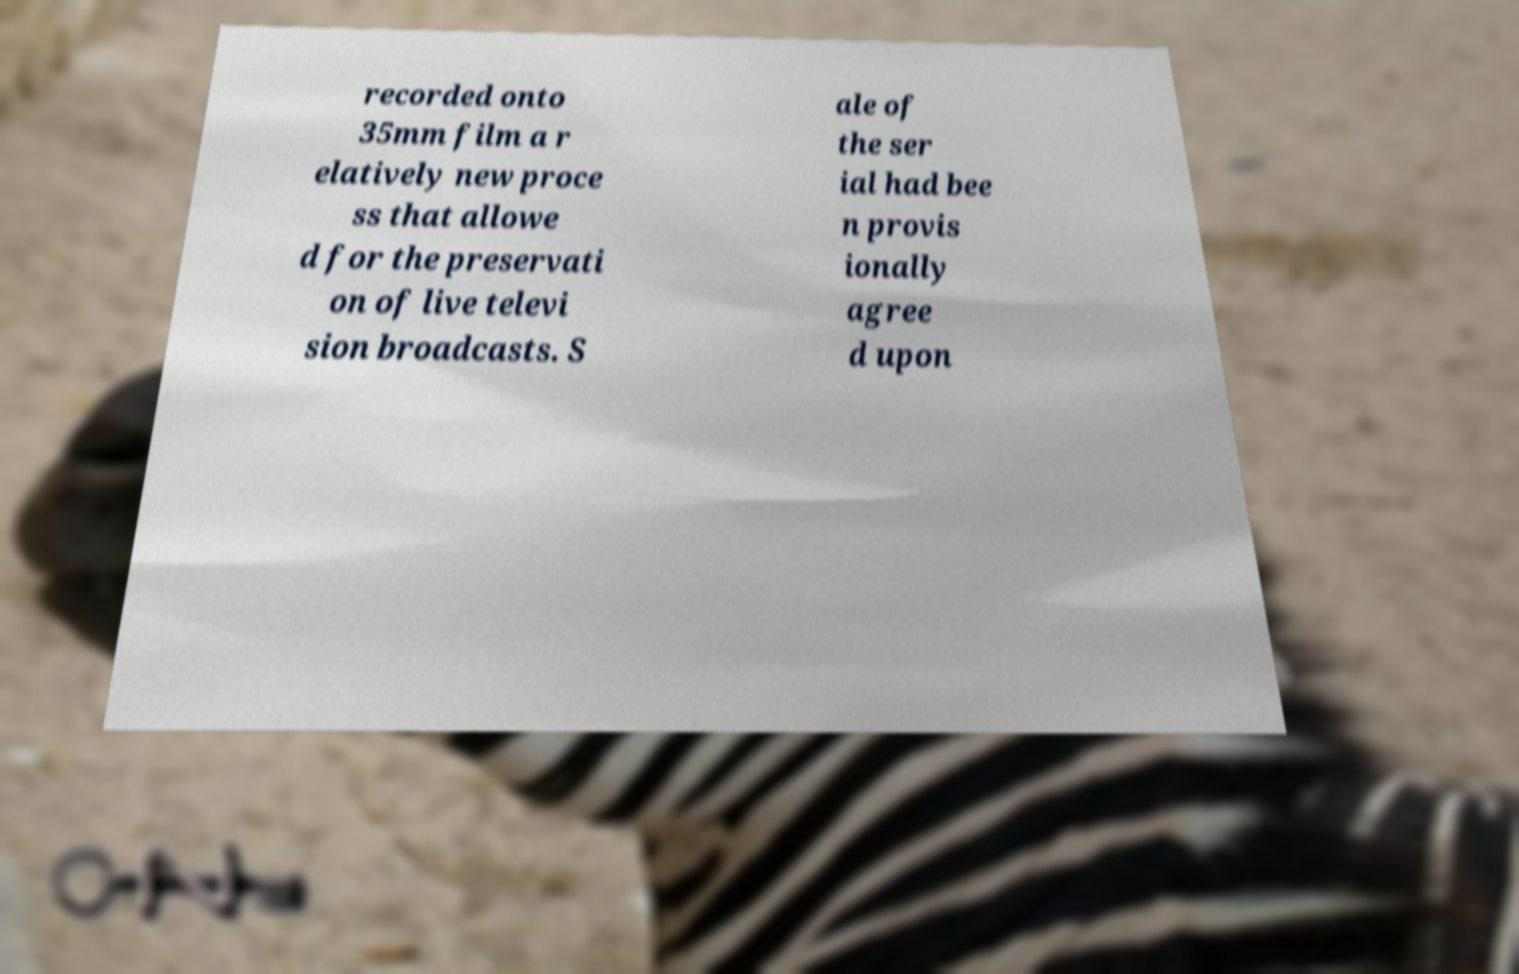I need the written content from this picture converted into text. Can you do that? recorded onto 35mm film a r elatively new proce ss that allowe d for the preservati on of live televi sion broadcasts. S ale of the ser ial had bee n provis ionally agree d upon 